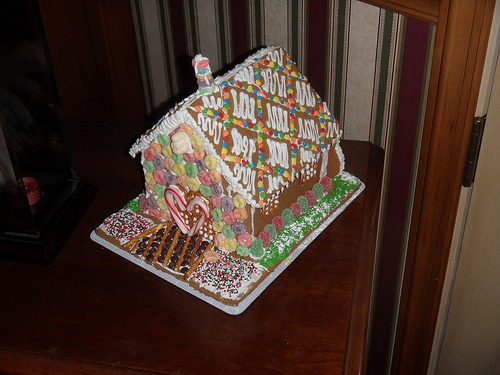<image>
Is the gingerbread house to the left of the table? No. The gingerbread house is not to the left of the table. From this viewpoint, they have a different horizontal relationship. Where is the gumdrop in relation to the table? Is it above the table? No. The gumdrop is not positioned above the table. The vertical arrangement shows a different relationship. 